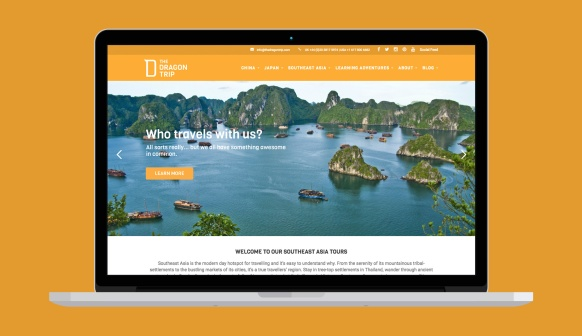How do you think the local wildlife contributes to the travel experience in this region? The local wildlife significantly enriches the travel experience in this region. From the playful monkeys in the dense jungles to the vibrant fish and coral in the surrounding waters, the biodiversity ensures that every moment is filled with awe and wonder. Travelers can expect to encounter colorful birds, monitor lizards, and perhaps even see elusive species such as Pythons or native monkeys. Whether on a guided tour with a naturalist, snorkeling among brush corals, or simply observing from their accommodation, the presence of diverse wildlife adds a layer of enchantment, making each trip memorable and unique. The local wildlife brings the natural beauty of the region to life, providing travelers with opportunities for bird watching, snorkeling, and nature walks, where they can observe the diverse flora and fauna in their natural habitats. 